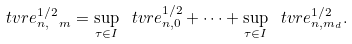Convert formula to latex. <formula><loc_0><loc_0><loc_500><loc_500>\ t v r e ^ { 1 / 2 } _ { n , \ m } = \sup _ { \tau \in I } \ t v r e ^ { 1 / 2 } _ { n , 0 } + \dots + \sup _ { \tau \in I } \ t v r e ^ { 1 / 2 } _ { n , m _ { d } } .</formula> 